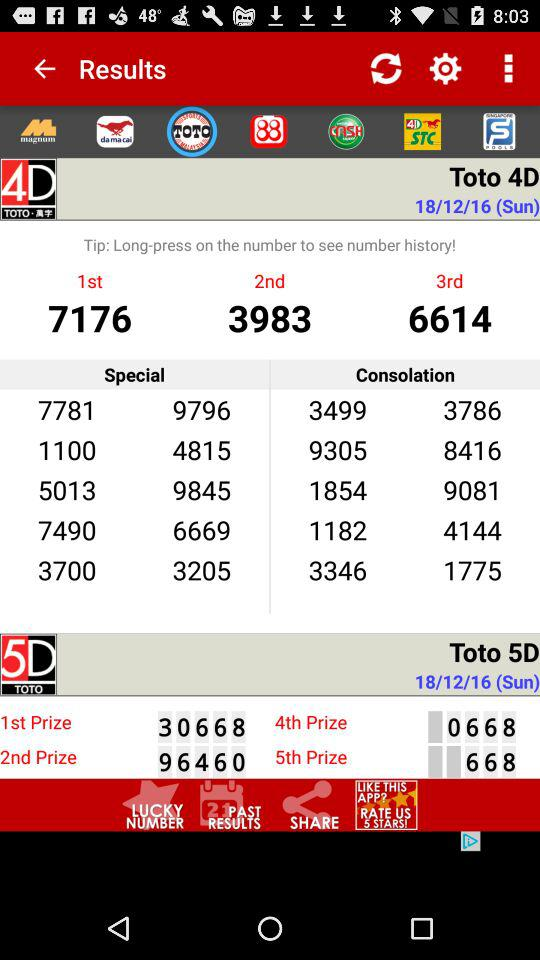What is the number for the first prize in "Toto 4D"? The number is 7176. 